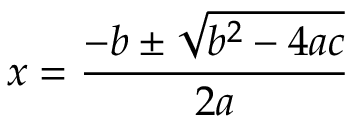Convert formula to latex. <formula><loc_0><loc_0><loc_500><loc_500>{ { x = { \frac { - b \pm { \sqrt { b ^ { 2 } - 4 a c } } } { 2 a } } } }</formula> 